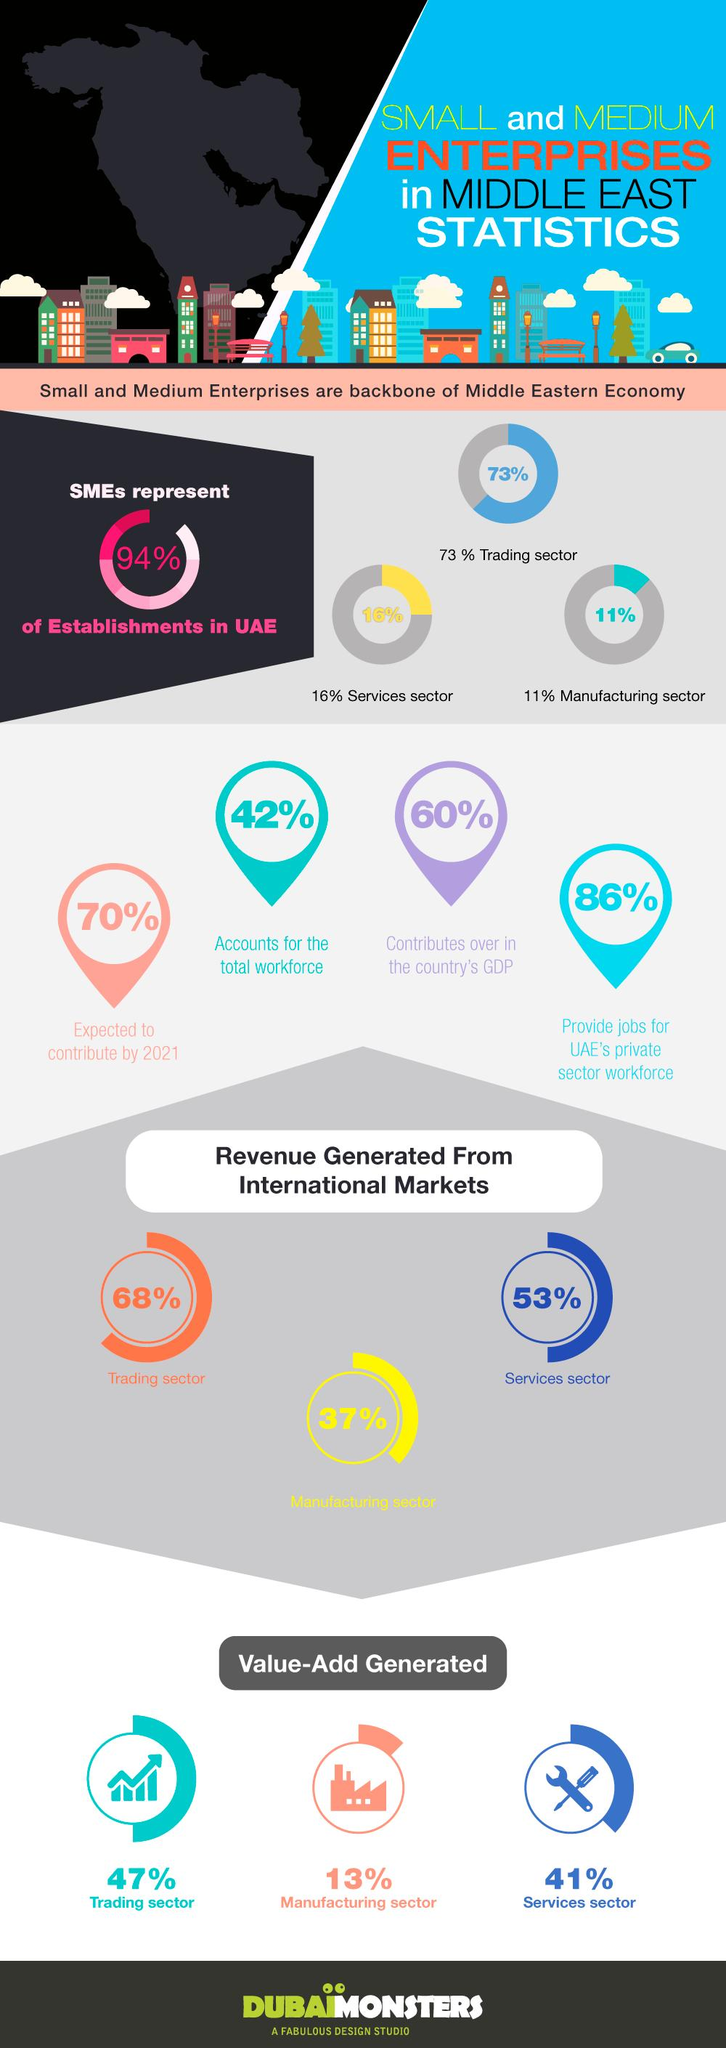Indicate a few pertinent items in this graphic. According to a recent survey, approximately 84% of enterprises in the Middle East are not in the services sector. Enterprises in the Middle East are grouped into three main sectors: the private sector, the public sector, and the mixed sector. According to a recent study, only 27% of enterprises in the Middle East are not engaged in trading. The inverse of value add generated in the trading sector is 53. The inverse of revenue generated in the manufacturing sector is the amount of resources and labor invested in the production process. 